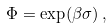<formula> <loc_0><loc_0><loc_500><loc_500>\Phi = \exp ( \beta \sigma ) \, ,</formula> 